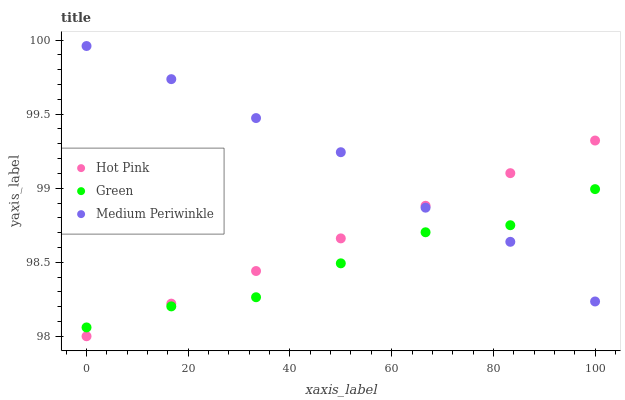Does Green have the minimum area under the curve?
Answer yes or no. Yes. Does Medium Periwinkle have the maximum area under the curve?
Answer yes or no. Yes. Does Hot Pink have the minimum area under the curve?
Answer yes or no. No. Does Hot Pink have the maximum area under the curve?
Answer yes or no. No. Is Hot Pink the smoothest?
Answer yes or no. Yes. Is Green the roughest?
Answer yes or no. Yes. Is Green the smoothest?
Answer yes or no. No. Is Hot Pink the roughest?
Answer yes or no. No. Does Hot Pink have the lowest value?
Answer yes or no. Yes. Does Green have the lowest value?
Answer yes or no. No. Does Medium Periwinkle have the highest value?
Answer yes or no. Yes. Does Hot Pink have the highest value?
Answer yes or no. No. Does Hot Pink intersect Green?
Answer yes or no. Yes. Is Hot Pink less than Green?
Answer yes or no. No. Is Hot Pink greater than Green?
Answer yes or no. No. 